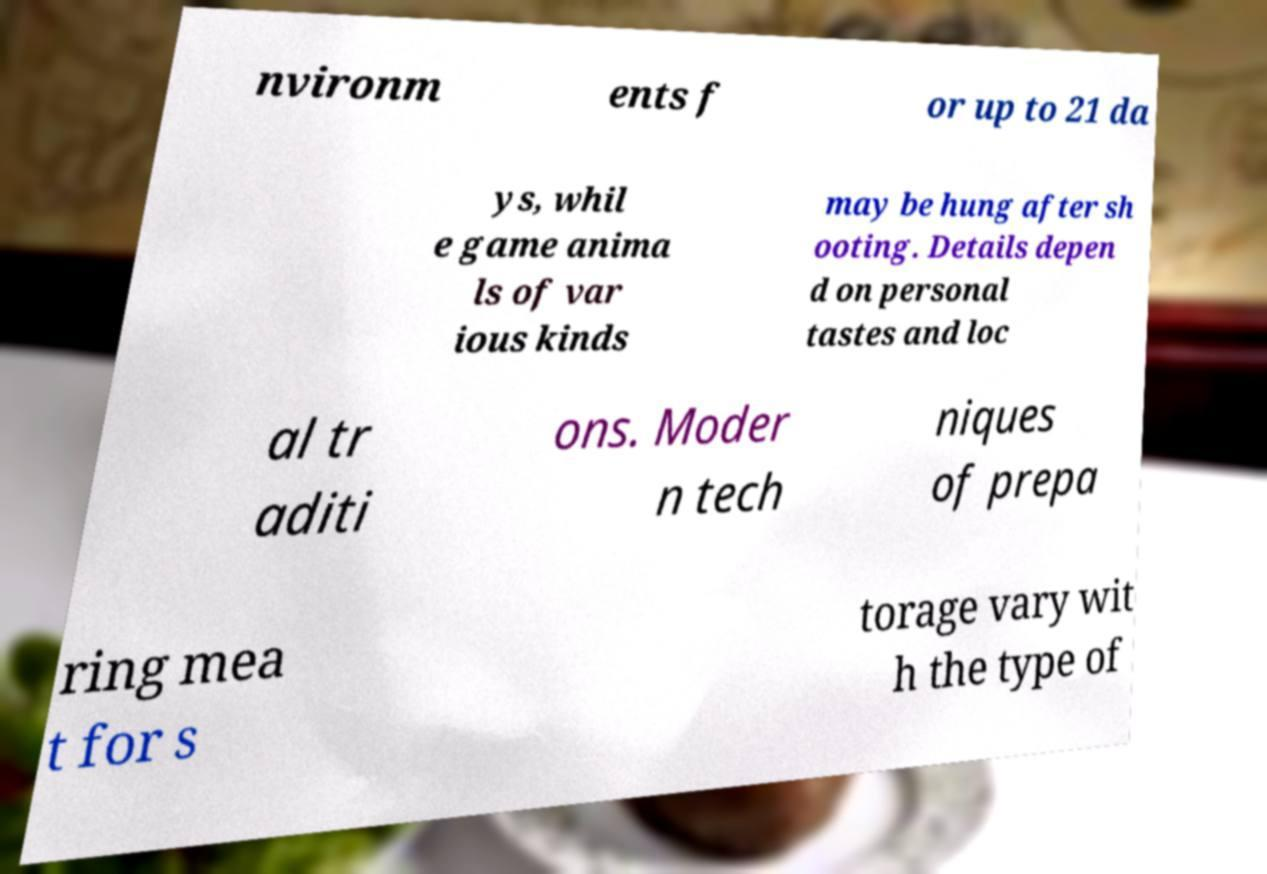Please read and relay the text visible in this image. What does it say? nvironm ents f or up to 21 da ys, whil e game anima ls of var ious kinds may be hung after sh ooting. Details depen d on personal tastes and loc al tr aditi ons. Moder n tech niques of prepa ring mea t for s torage vary wit h the type of 